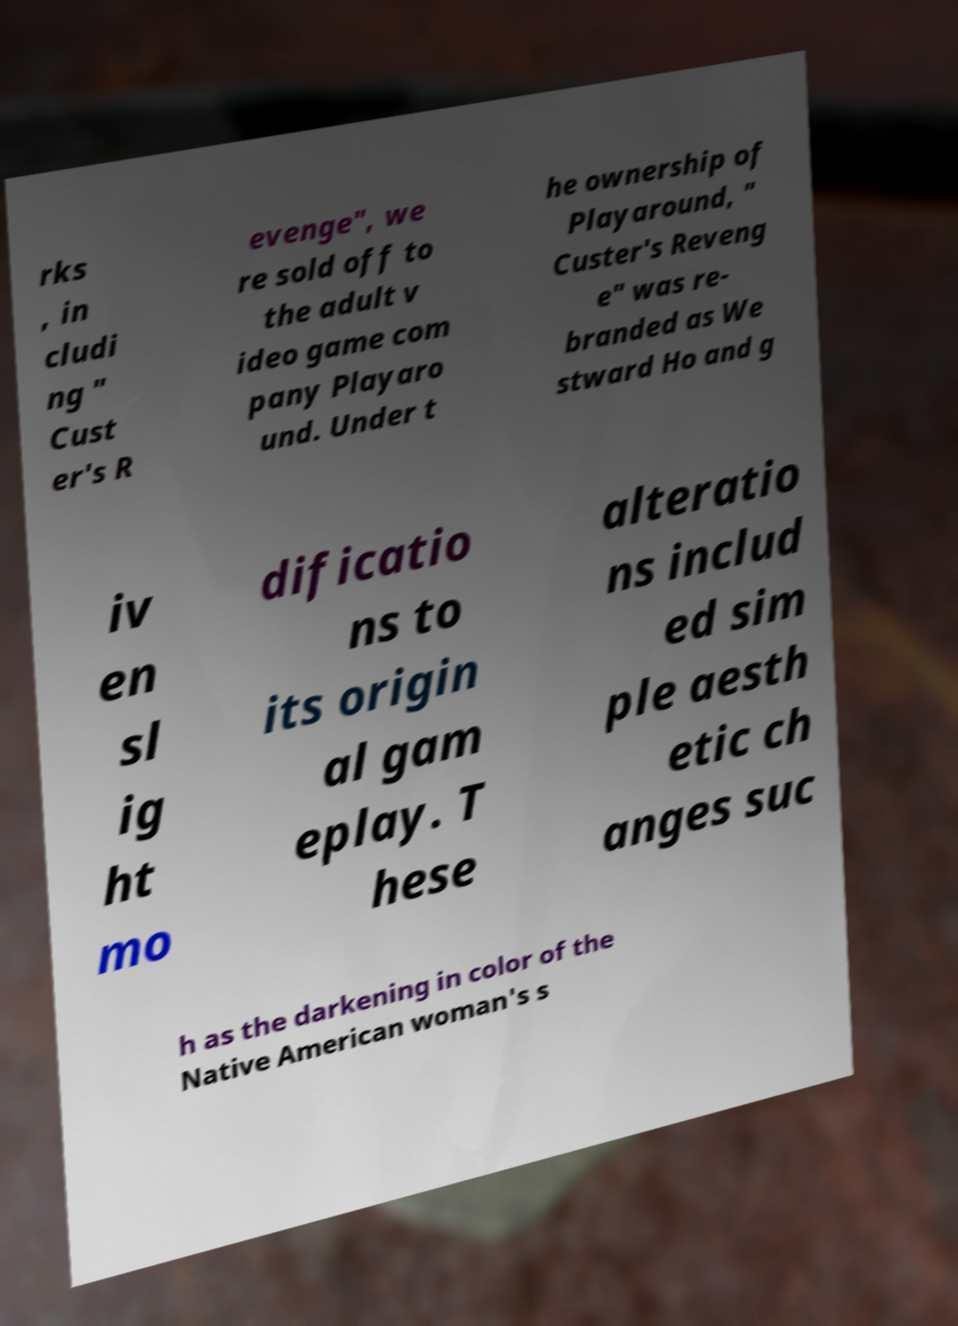Can you accurately transcribe the text from the provided image for me? rks , in cludi ng " Cust er's R evenge", we re sold off to the adult v ideo game com pany Playaro und. Under t he ownership of Playaround, " Custer's Reveng e" was re- branded as We stward Ho and g iv en sl ig ht mo dificatio ns to its origin al gam eplay. T hese alteratio ns includ ed sim ple aesth etic ch anges suc h as the darkening in color of the Native American woman's s 